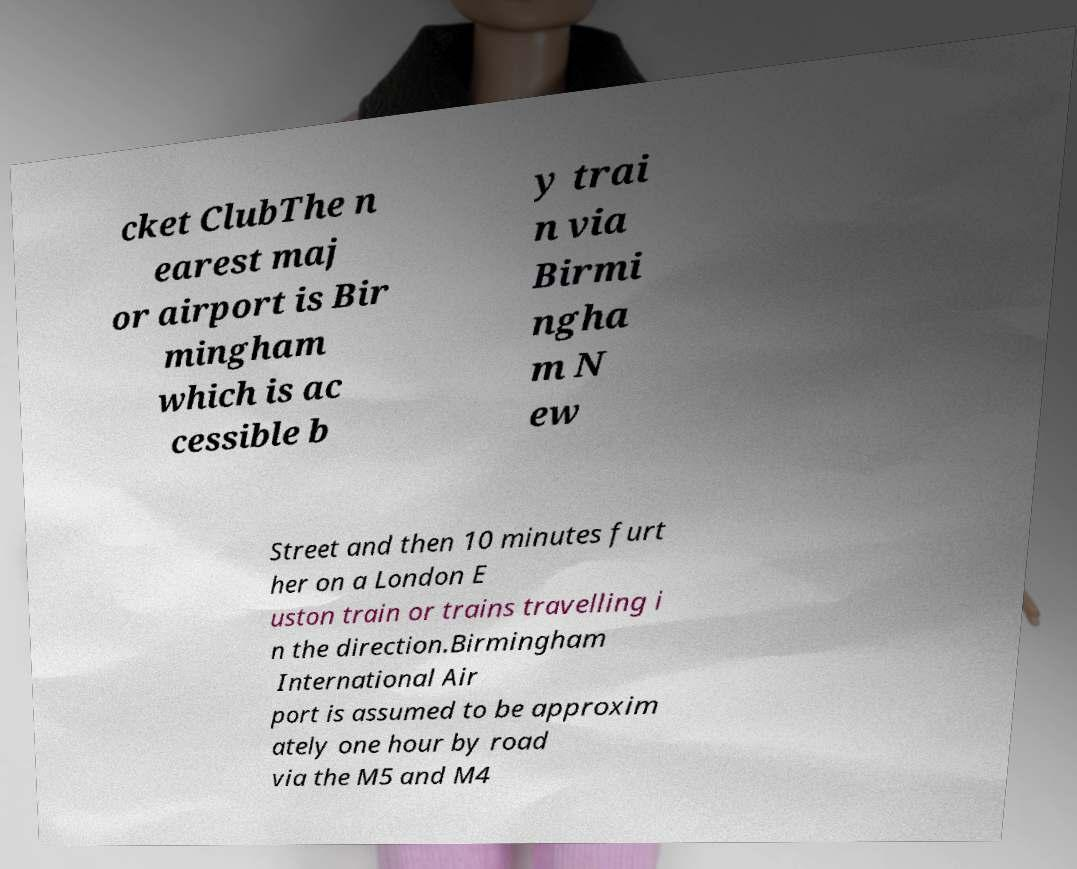Please read and relay the text visible in this image. What does it say? cket ClubThe n earest maj or airport is Bir mingham which is ac cessible b y trai n via Birmi ngha m N ew Street and then 10 minutes furt her on a London E uston train or trains travelling i n the direction.Birmingham International Air port is assumed to be approxim ately one hour by road via the M5 and M4 